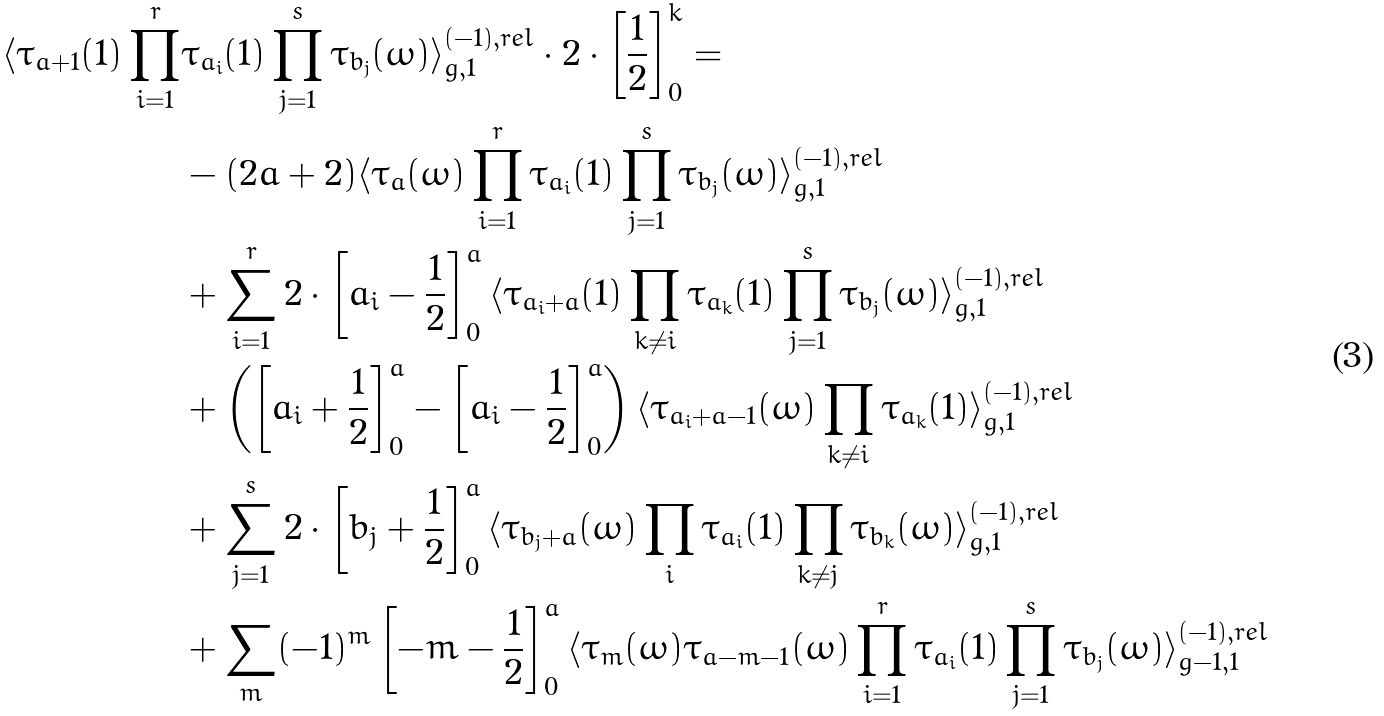Convert formula to latex. <formula><loc_0><loc_0><loc_500><loc_500>\langle \tau _ { a + 1 } ( 1 ) \prod _ { i = 1 } ^ { r } & \tau _ { a _ { i } } ( 1 ) \prod _ { j = 1 } ^ { s } \tau _ { b _ { j } } ( \omega ) \rangle ^ { ( - 1 ) , r e l } _ { g , 1 } \cdot 2 \cdot \left [ \frac { 1 } { 2 } \right ] ^ { k } _ { 0 } = \\ & - ( 2 a + 2 ) \langle \tau _ { a } ( \omega ) \prod _ { i = 1 } ^ { r } \tau _ { a _ { i } } ( 1 ) \prod _ { j = 1 } ^ { s } \tau _ { b _ { j } } ( \omega ) \rangle ^ { ( - 1 ) , r e l } _ { g , 1 } \\ & + \sum _ { i = 1 } ^ { r } 2 \cdot \left [ a _ { i } - \frac { 1 } { 2 } \right ] ^ { a } _ { 0 } \langle \tau _ { a _ { i } + a } ( 1 ) \prod _ { k \neq i } \tau _ { a _ { k } } ( 1 ) \prod _ { j = 1 } ^ { s } \tau _ { b _ { j } } ( \omega ) \rangle ^ { ( - 1 ) , r e l } _ { g , 1 } \\ & + \left ( \left [ a _ { i } + \frac { 1 } { 2 } \right ] ^ { a } _ { 0 } - \left [ a _ { i } - \frac { 1 } { 2 } \right ] ^ { a } _ { 0 } \right ) \langle \tau _ { a _ { i } + a - 1 } ( \omega ) \prod _ { k \neq i } \tau _ { a _ { k } } ( 1 ) \rangle ^ { ( - 1 ) , r e l } _ { g , 1 } \\ & + \sum _ { j = 1 } ^ { s } 2 \cdot \left [ b _ { j } + \frac { 1 } { 2 } \right ] ^ { a } _ { 0 } \langle \tau _ { b _ { j } + a } ( \omega ) \prod _ { i } \tau _ { a _ { i } } ( 1 ) \prod _ { k \neq j } \tau _ { b _ { k } } ( \omega ) \rangle ^ { ( - 1 ) , r e l } _ { g , 1 } \\ & + \sum _ { m } ( - 1 ) ^ { m } \left [ - m - \frac { 1 } { 2 } \right ] ^ { a } _ { 0 } \langle \tau _ { m } ( \omega ) \tau _ { a - m - 1 } ( \omega ) \prod _ { i = 1 } ^ { r } \tau _ { a _ { i } } ( 1 ) \prod _ { j = 1 } ^ { s } \tau _ { b _ { j } } ( \omega ) \rangle ^ { ( - 1 ) , r e l } _ { g - 1 , 1 }</formula> 